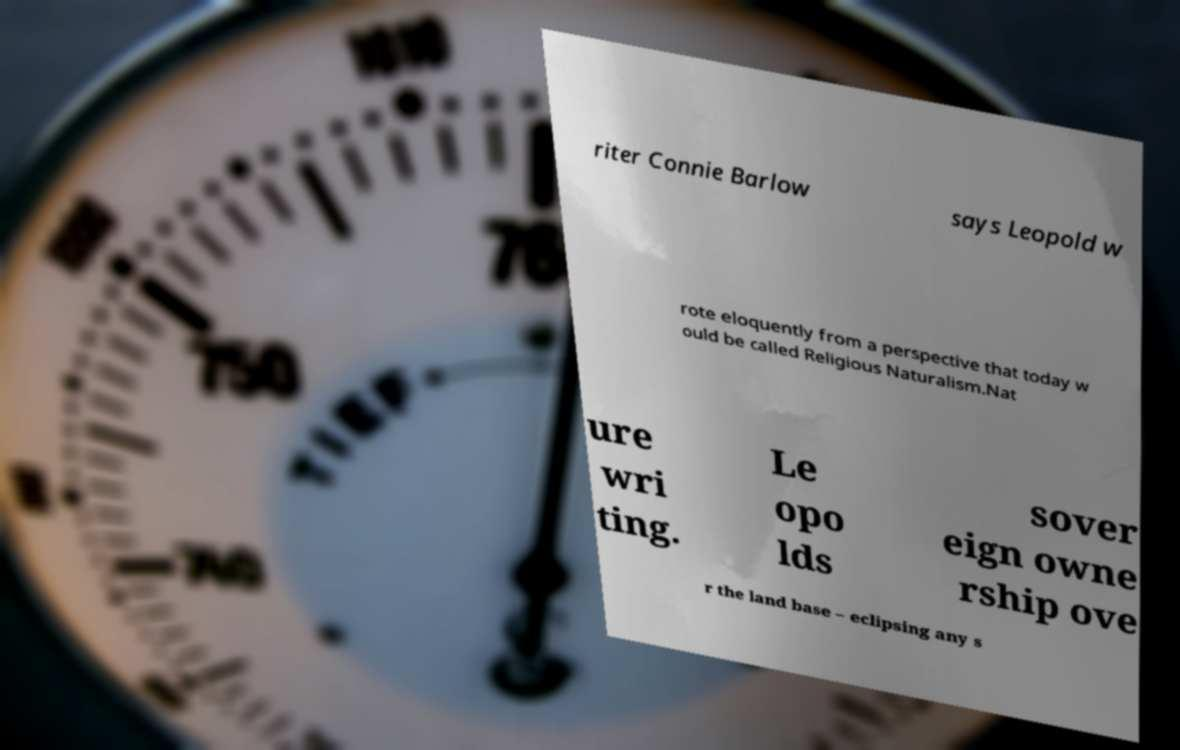Please read and relay the text visible in this image. What does it say? riter Connie Barlow says Leopold w rote eloquently from a perspective that today w ould be called Religious Naturalism.Nat ure wri ting. Le opo lds sover eign owne rship ove r the land base – eclipsing any s 